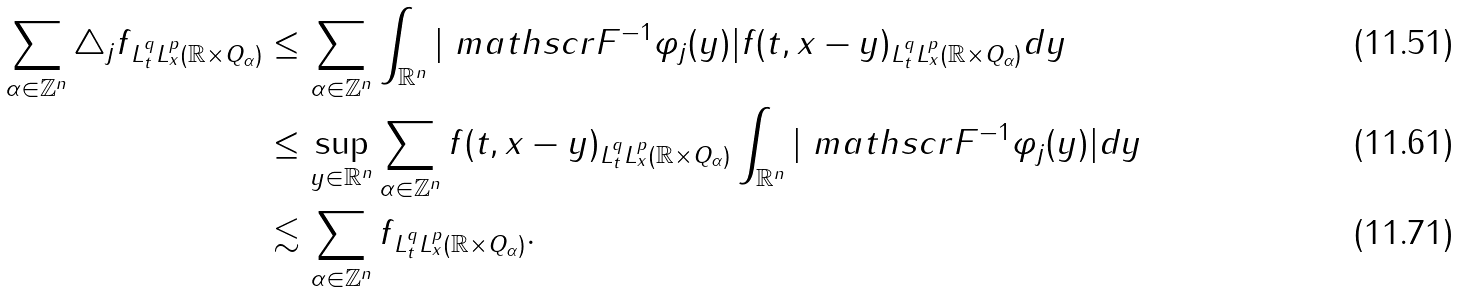Convert formula to latex. <formula><loc_0><loc_0><loc_500><loc_500>\sum _ { \alpha \in \mathbb { Z } ^ { n } } \| \triangle _ { j } f \| _ { L ^ { q } _ { t } L ^ { p } _ { x } ( \mathbb { R } \times Q _ { \alpha } ) } & \leq \sum _ { \alpha \in \mathbb { Z } ^ { n } } \int _ { \mathbb { R } ^ { n } } | \ m a t h s c r { F } ^ { - 1 } \varphi _ { j } ( y ) | \| f ( t , x - y ) \| _ { L ^ { q } _ { t } L ^ { p } _ { x } ( \mathbb { R } \times Q _ { \alpha } ) } d y \\ & \leq \sup _ { y \in \mathbb { R } ^ { n } } \sum _ { \alpha \in \mathbb { Z } ^ { n } } \| f ( t , x - y ) \| _ { L ^ { q } _ { t } L ^ { p } _ { x } ( \mathbb { R } \times Q _ { \alpha } ) } \int _ { \mathbb { R } ^ { n } } | \ m a t h s c r { F } ^ { - 1 } \varphi _ { j } ( y ) | d y \\ & \lesssim \sum _ { \alpha \in \mathbb { Z } ^ { n } } \| f \| _ { L ^ { q } _ { t } L ^ { p } _ { x } ( \mathbb { R } \times Q _ { \alpha } ) } .</formula> 